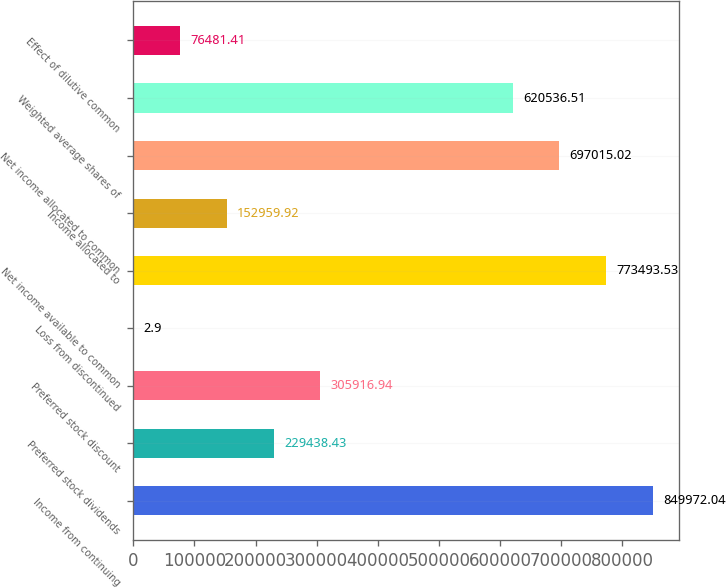Convert chart to OTSL. <chart><loc_0><loc_0><loc_500><loc_500><bar_chart><fcel>Income from continuing<fcel>Preferred stock dividends<fcel>Preferred stock discount<fcel>Loss from discontinued<fcel>Net income available to common<fcel>Income allocated to<fcel>Net income allocated to common<fcel>Weighted average shares of<fcel>Effect of dilutive common<nl><fcel>849972<fcel>229438<fcel>305917<fcel>2.9<fcel>773494<fcel>152960<fcel>697015<fcel>620537<fcel>76481.4<nl></chart> 